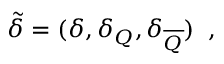Convert formula to latex. <formula><loc_0><loc_0><loc_500><loc_500>\tilde { \delta } = ( \delta , \delta _ { Q } , \delta _ { \overline { Q } } ) \, ,</formula> 